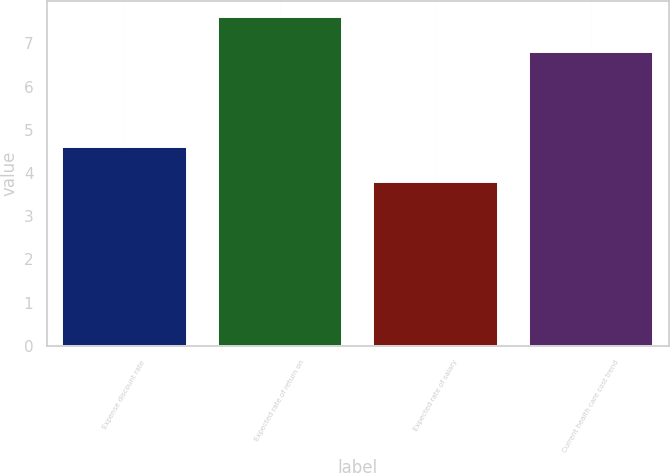Convert chart to OTSL. <chart><loc_0><loc_0><loc_500><loc_500><bar_chart><fcel>Expense discount rate<fcel>Expected rate of return on<fcel>Expected rate of salary<fcel>Current health care cost trend<nl><fcel>4.6<fcel>7.6<fcel>3.8<fcel>6.8<nl></chart> 